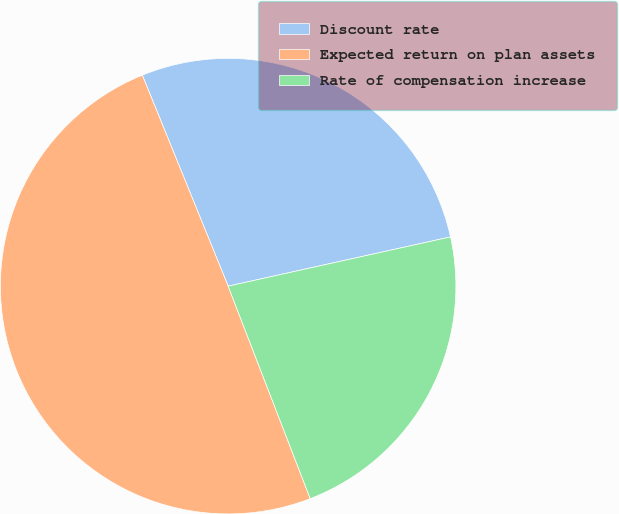<chart> <loc_0><loc_0><loc_500><loc_500><pie_chart><fcel>Discount rate<fcel>Expected return on plan assets<fcel>Rate of compensation increase<nl><fcel>27.68%<fcel>49.72%<fcel>22.6%<nl></chart> 